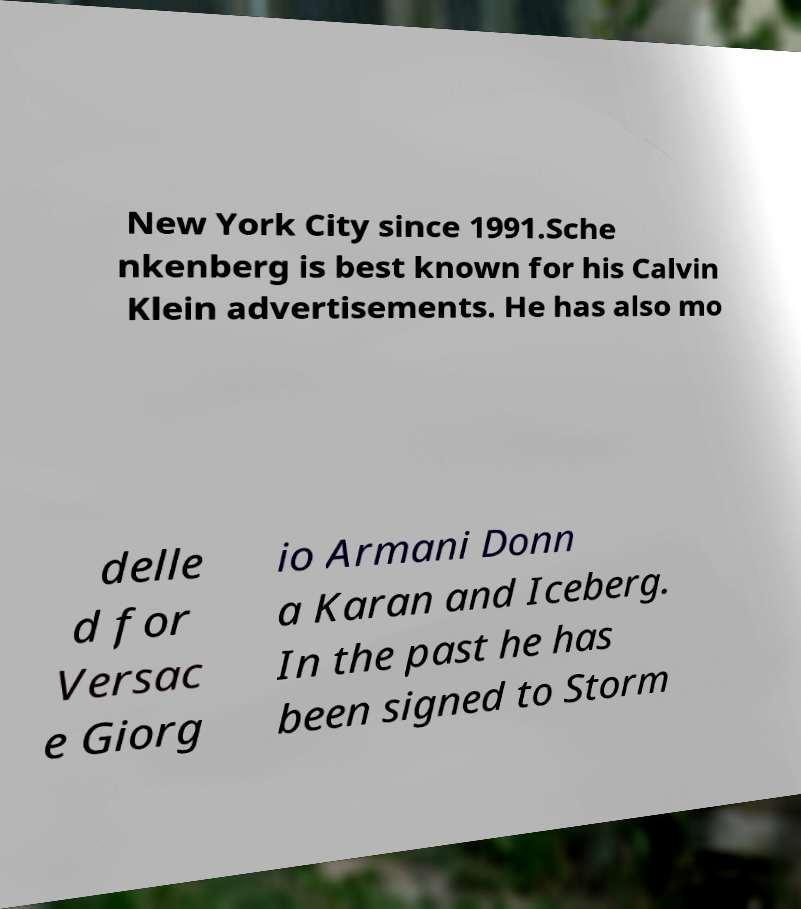What messages or text are displayed in this image? I need them in a readable, typed format. New York City since 1991.Sche nkenberg is best known for his Calvin Klein advertisements. He has also mo delle d for Versac e Giorg io Armani Donn a Karan and Iceberg. In the past he has been signed to Storm 